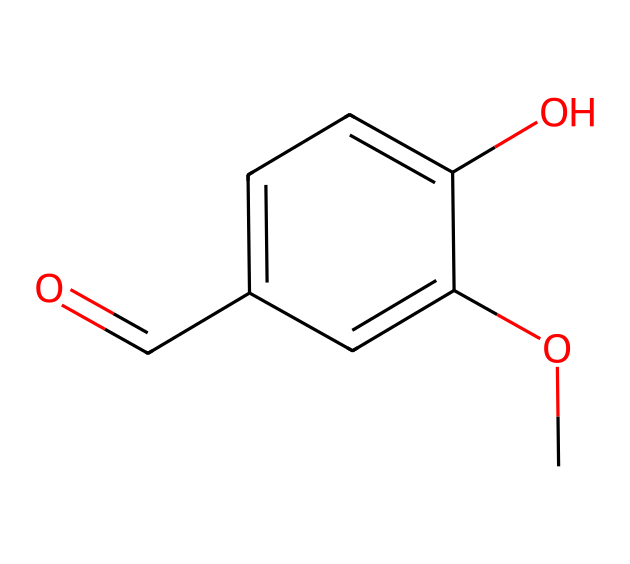What is the total number of carbon atoms in vanillin? By examining the SMILES representation, we identify all the carbon atoms present in the structure. The structure has a total of eight carbon atoms, indicated by the number of 'C' in the structure.
Answer: eight How many functional groups are present in vanillin? The chemical structure shows a carbonyl group (C=O) and a methoxy group (–OCH3), giving us two distinct functional groups.
Answer: two What type of compound is vanillin classified as? Based on the presence of the aromatic ring and the functional groups, vanillin can be classified as an aromatic aldehyde.
Answer: aromatic aldehyde Which functional group is responsible for the sweet flavor of vanillin? The aldehyde functional group (C=O) is primarily responsible for the characteristic sweet flavor, as it is commonly associated with flavoring compounds.
Answer: aldehyde How many oxygen atoms are present in vanillin? By examining the SMILES representation, we can count two oxygen atoms in the structure, one from the carbonyl group and one from the methoxy group.
Answer: two What is the role of the methoxy group in vanillin's properties? The methoxy group (–OCH3) helps enhance the sweetness and solubility of vanillin, contributing to its effectiveness as a flavoring agent.
Answer: enhances sweetness How does the structure of vanillin affect its volatility? The presence of both the aromatic ring and functional groups, such as the aldehyde and methoxy groups, influences the volatility. Aromatic compounds often have lower volatility compared to aliphatic compounds due to stronger intermolecular forces.
Answer: lowers volatility 